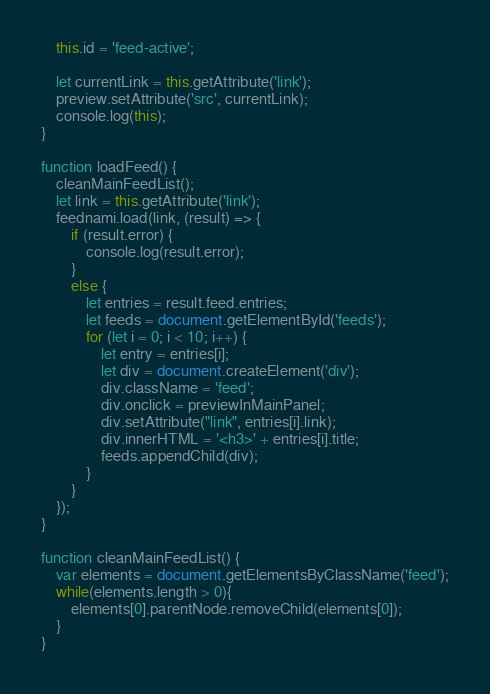<code> <loc_0><loc_0><loc_500><loc_500><_JavaScript_>    this.id = 'feed-active';

    let currentLink = this.getAttribute('link');
    preview.setAttribute('src', currentLink);
    console.log(this);
}

function loadFeed() {
    cleanMainFeedList();
    let link = this.getAttribute('link');
    feednami.load(link, (result) => {
        if (result.error) {
            console.log(result.error);
        } 
        else {
            let entries = result.feed.entries;
            let feeds = document.getElementById('feeds');
            for (let i = 0; i < 10; i++) {
                let entry = entries[i];
                let div = document.createElement('div');
                div.className = 'feed';
                div.onclick = previewInMainPanel;
                div.setAttribute("link", entries[i].link);
                div.innerHTML = '<h3>' + entries[i].title;
                feeds.appendChild(div);
            }
        }
    });
}

function cleanMainFeedList() {
    var elements = document.getElementsByClassName('feed');
    while(elements.length > 0){
        elements[0].parentNode.removeChild(elements[0]);
    }
}
</code> 